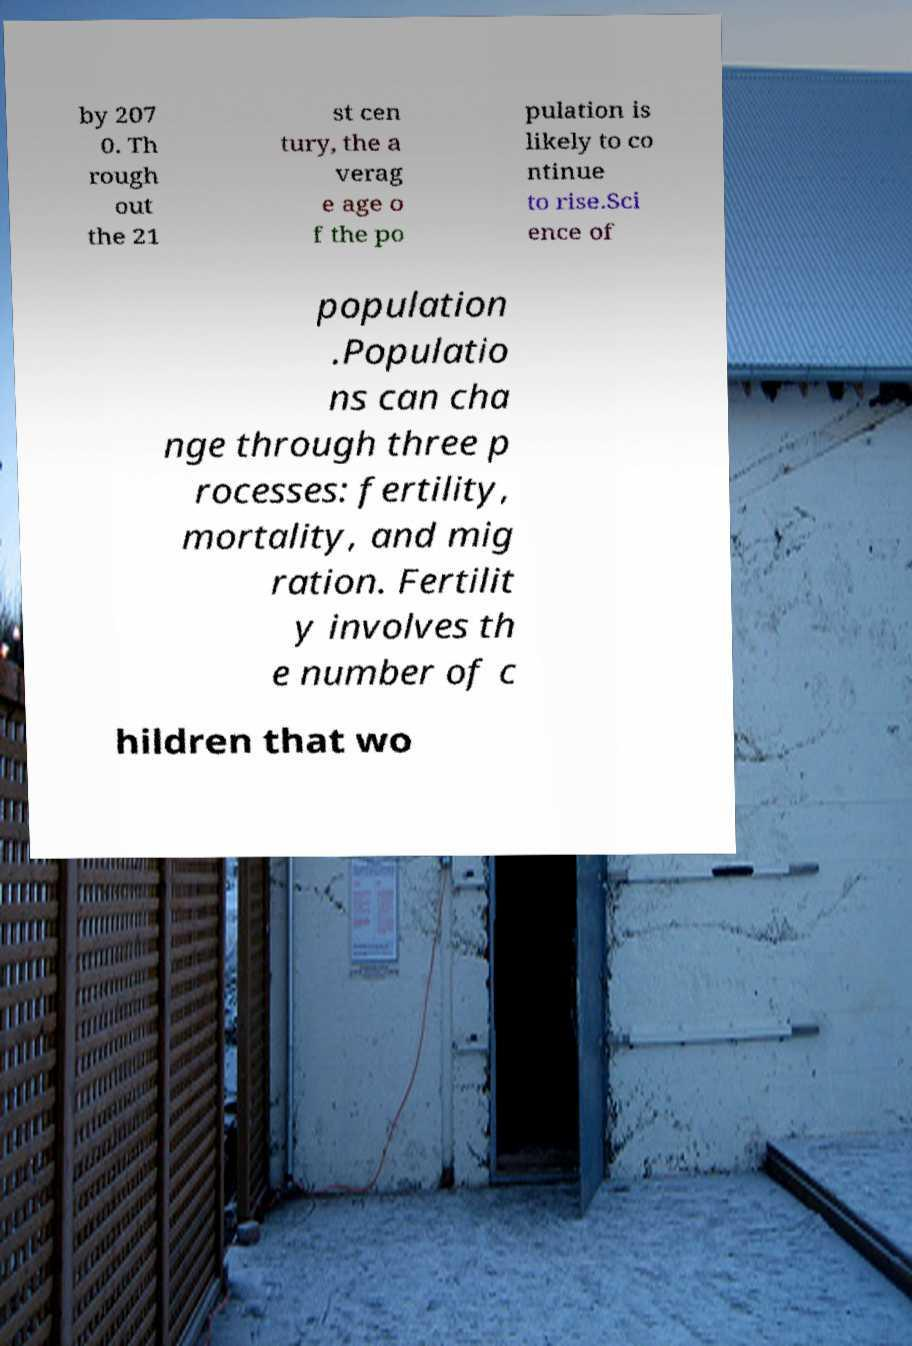Can you accurately transcribe the text from the provided image for me? by 207 0. Th rough out the 21 st cen tury, the a verag e age o f the po pulation is likely to co ntinue to rise.Sci ence of population .Populatio ns can cha nge through three p rocesses: fertility, mortality, and mig ration. Fertilit y involves th e number of c hildren that wo 